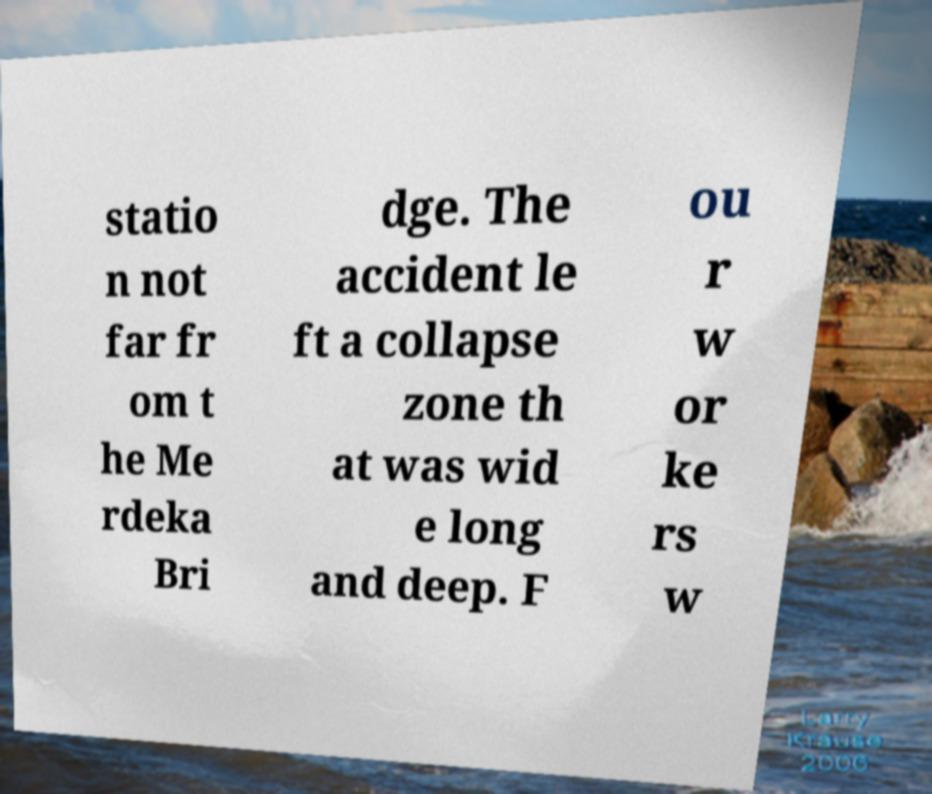Could you extract and type out the text from this image? statio n not far fr om t he Me rdeka Bri dge. The accident le ft a collapse zone th at was wid e long and deep. F ou r w or ke rs w 